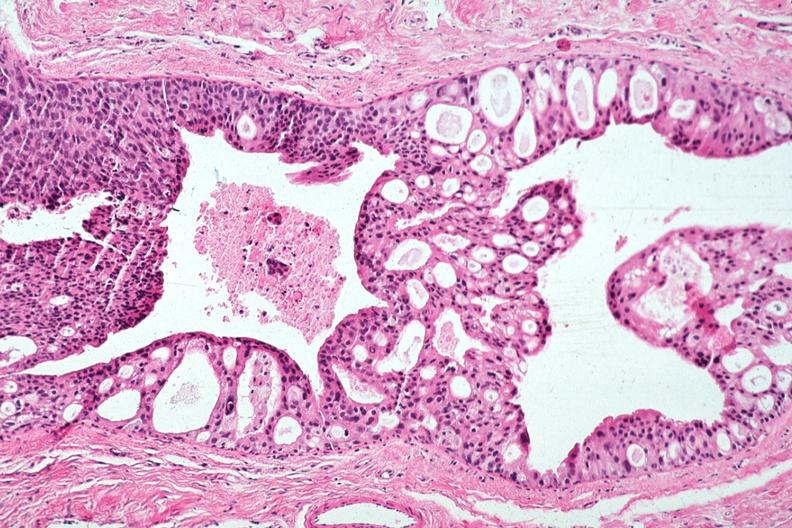s papillary intraductal adenocarcinoma present?
Answer the question using a single word or phrase. Yes 